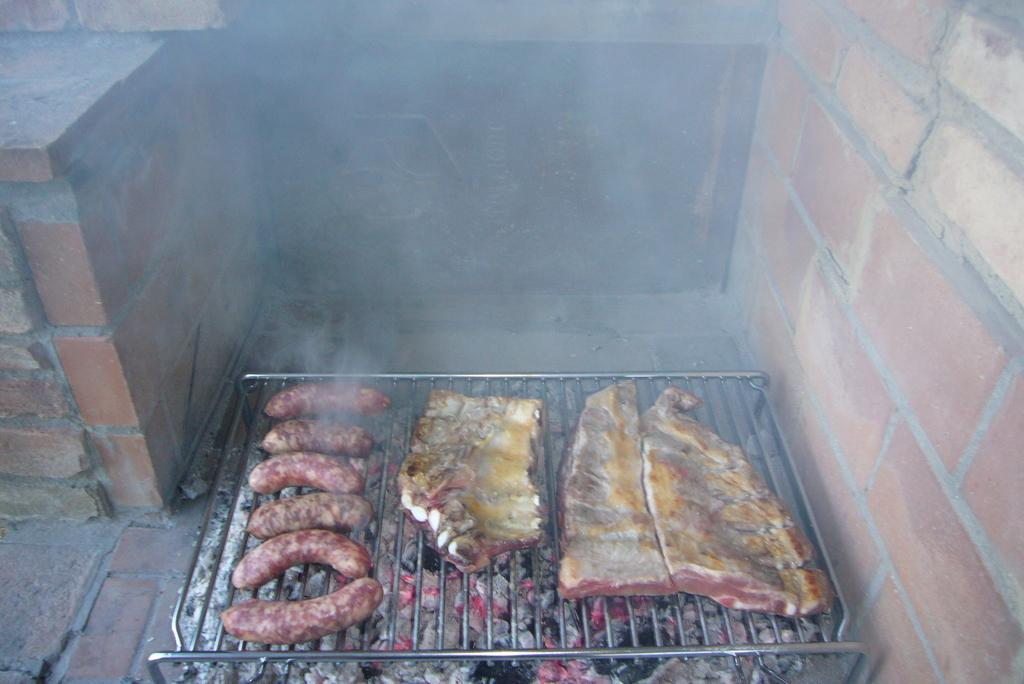What is the main object in the image? There is a grill in the image. What is being cooked on the grill? There is meat placed on the grill. What can be seen in the background of the image? There is a brick wall in the background of the image. How do the trousers compare to the grill in the image? There are no trousers present in the image, so it is not possible to make a comparison. 